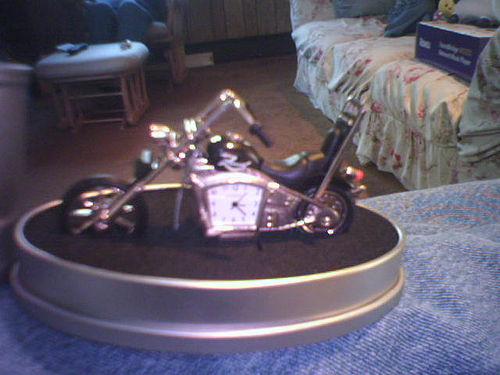What type of clock is this?
Answer briefly. Motorcycle. Will this motorcycle roll?
Short answer required. No. Is this a living area?
Keep it brief. Yes. 